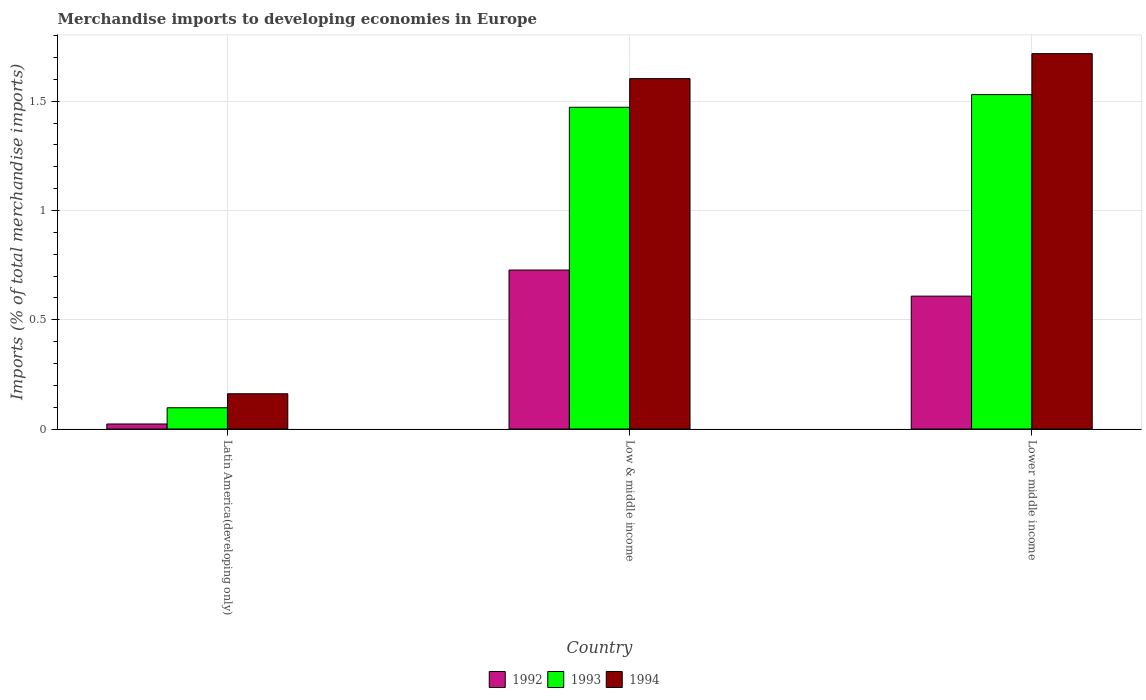How many different coloured bars are there?
Offer a terse response. 3. Are the number of bars per tick equal to the number of legend labels?
Offer a terse response. Yes. Are the number of bars on each tick of the X-axis equal?
Provide a short and direct response. Yes. What is the label of the 3rd group of bars from the left?
Provide a short and direct response. Lower middle income. What is the percentage total merchandise imports in 1994 in Lower middle income?
Make the answer very short. 1.72. Across all countries, what is the maximum percentage total merchandise imports in 1993?
Offer a very short reply. 1.53. Across all countries, what is the minimum percentage total merchandise imports in 1994?
Provide a short and direct response. 0.16. In which country was the percentage total merchandise imports in 1992 minimum?
Ensure brevity in your answer.  Latin America(developing only). What is the total percentage total merchandise imports in 1992 in the graph?
Keep it short and to the point. 1.36. What is the difference between the percentage total merchandise imports in 1992 in Latin America(developing only) and that in Lower middle income?
Offer a very short reply. -0.59. What is the difference between the percentage total merchandise imports in 1994 in Lower middle income and the percentage total merchandise imports in 1992 in Latin America(developing only)?
Your answer should be compact. 1.7. What is the average percentage total merchandise imports in 1993 per country?
Provide a short and direct response. 1.03. What is the difference between the percentage total merchandise imports of/in 1993 and percentage total merchandise imports of/in 1994 in Latin America(developing only)?
Give a very brief answer. -0.06. What is the ratio of the percentage total merchandise imports in 1994 in Latin America(developing only) to that in Lower middle income?
Offer a terse response. 0.09. Is the percentage total merchandise imports in 1994 in Latin America(developing only) less than that in Low & middle income?
Give a very brief answer. Yes. Is the difference between the percentage total merchandise imports in 1993 in Latin America(developing only) and Lower middle income greater than the difference between the percentage total merchandise imports in 1994 in Latin America(developing only) and Lower middle income?
Your answer should be very brief. Yes. What is the difference between the highest and the second highest percentage total merchandise imports in 1993?
Your response must be concise. -1.43. What is the difference between the highest and the lowest percentage total merchandise imports in 1994?
Provide a short and direct response. 1.56. In how many countries, is the percentage total merchandise imports in 1994 greater than the average percentage total merchandise imports in 1994 taken over all countries?
Offer a terse response. 2. How many bars are there?
Your answer should be compact. 9. Are all the bars in the graph horizontal?
Your answer should be very brief. No. What is the difference between two consecutive major ticks on the Y-axis?
Your answer should be compact. 0.5. Are the values on the major ticks of Y-axis written in scientific E-notation?
Provide a succinct answer. No. Does the graph contain any zero values?
Keep it short and to the point. No. Does the graph contain grids?
Ensure brevity in your answer.  Yes. What is the title of the graph?
Your answer should be compact. Merchandise imports to developing economies in Europe. What is the label or title of the Y-axis?
Offer a very short reply. Imports (% of total merchandise imports). What is the Imports (% of total merchandise imports) of 1992 in Latin America(developing only)?
Keep it short and to the point. 0.02. What is the Imports (% of total merchandise imports) in 1993 in Latin America(developing only)?
Provide a short and direct response. 0.1. What is the Imports (% of total merchandise imports) of 1994 in Latin America(developing only)?
Offer a very short reply. 0.16. What is the Imports (% of total merchandise imports) of 1992 in Low & middle income?
Give a very brief answer. 0.73. What is the Imports (% of total merchandise imports) in 1993 in Low & middle income?
Ensure brevity in your answer.  1.47. What is the Imports (% of total merchandise imports) of 1994 in Low & middle income?
Your answer should be very brief. 1.6. What is the Imports (% of total merchandise imports) in 1992 in Lower middle income?
Give a very brief answer. 0.61. What is the Imports (% of total merchandise imports) of 1993 in Lower middle income?
Provide a short and direct response. 1.53. What is the Imports (% of total merchandise imports) of 1994 in Lower middle income?
Offer a very short reply. 1.72. Across all countries, what is the maximum Imports (% of total merchandise imports) of 1992?
Your answer should be compact. 0.73. Across all countries, what is the maximum Imports (% of total merchandise imports) in 1993?
Keep it short and to the point. 1.53. Across all countries, what is the maximum Imports (% of total merchandise imports) in 1994?
Your answer should be compact. 1.72. Across all countries, what is the minimum Imports (% of total merchandise imports) of 1992?
Make the answer very short. 0.02. Across all countries, what is the minimum Imports (% of total merchandise imports) of 1993?
Provide a short and direct response. 0.1. Across all countries, what is the minimum Imports (% of total merchandise imports) of 1994?
Your response must be concise. 0.16. What is the total Imports (% of total merchandise imports) of 1992 in the graph?
Keep it short and to the point. 1.36. What is the total Imports (% of total merchandise imports) in 1993 in the graph?
Keep it short and to the point. 3.1. What is the total Imports (% of total merchandise imports) in 1994 in the graph?
Provide a succinct answer. 3.48. What is the difference between the Imports (% of total merchandise imports) in 1992 in Latin America(developing only) and that in Low & middle income?
Make the answer very short. -0.7. What is the difference between the Imports (% of total merchandise imports) of 1993 in Latin America(developing only) and that in Low & middle income?
Give a very brief answer. -1.38. What is the difference between the Imports (% of total merchandise imports) of 1994 in Latin America(developing only) and that in Low & middle income?
Your answer should be compact. -1.44. What is the difference between the Imports (% of total merchandise imports) in 1992 in Latin America(developing only) and that in Lower middle income?
Your answer should be compact. -0.59. What is the difference between the Imports (% of total merchandise imports) in 1993 in Latin America(developing only) and that in Lower middle income?
Your response must be concise. -1.43. What is the difference between the Imports (% of total merchandise imports) in 1994 in Latin America(developing only) and that in Lower middle income?
Your answer should be compact. -1.56. What is the difference between the Imports (% of total merchandise imports) of 1992 in Low & middle income and that in Lower middle income?
Offer a very short reply. 0.12. What is the difference between the Imports (% of total merchandise imports) in 1993 in Low & middle income and that in Lower middle income?
Keep it short and to the point. -0.06. What is the difference between the Imports (% of total merchandise imports) of 1994 in Low & middle income and that in Lower middle income?
Your response must be concise. -0.11. What is the difference between the Imports (% of total merchandise imports) in 1992 in Latin America(developing only) and the Imports (% of total merchandise imports) in 1993 in Low & middle income?
Offer a very short reply. -1.45. What is the difference between the Imports (% of total merchandise imports) in 1992 in Latin America(developing only) and the Imports (% of total merchandise imports) in 1994 in Low & middle income?
Offer a very short reply. -1.58. What is the difference between the Imports (% of total merchandise imports) in 1993 in Latin America(developing only) and the Imports (% of total merchandise imports) in 1994 in Low & middle income?
Provide a short and direct response. -1.51. What is the difference between the Imports (% of total merchandise imports) of 1992 in Latin America(developing only) and the Imports (% of total merchandise imports) of 1993 in Lower middle income?
Give a very brief answer. -1.51. What is the difference between the Imports (% of total merchandise imports) in 1992 in Latin America(developing only) and the Imports (% of total merchandise imports) in 1994 in Lower middle income?
Provide a succinct answer. -1.7. What is the difference between the Imports (% of total merchandise imports) of 1993 in Latin America(developing only) and the Imports (% of total merchandise imports) of 1994 in Lower middle income?
Provide a succinct answer. -1.62. What is the difference between the Imports (% of total merchandise imports) in 1992 in Low & middle income and the Imports (% of total merchandise imports) in 1993 in Lower middle income?
Ensure brevity in your answer.  -0.8. What is the difference between the Imports (% of total merchandise imports) of 1992 in Low & middle income and the Imports (% of total merchandise imports) of 1994 in Lower middle income?
Ensure brevity in your answer.  -0.99. What is the difference between the Imports (% of total merchandise imports) in 1993 in Low & middle income and the Imports (% of total merchandise imports) in 1994 in Lower middle income?
Your answer should be very brief. -0.25. What is the average Imports (% of total merchandise imports) in 1992 per country?
Offer a very short reply. 0.45. What is the average Imports (% of total merchandise imports) of 1993 per country?
Keep it short and to the point. 1.03. What is the average Imports (% of total merchandise imports) in 1994 per country?
Your answer should be compact. 1.16. What is the difference between the Imports (% of total merchandise imports) in 1992 and Imports (% of total merchandise imports) in 1993 in Latin America(developing only)?
Your response must be concise. -0.07. What is the difference between the Imports (% of total merchandise imports) of 1992 and Imports (% of total merchandise imports) of 1994 in Latin America(developing only)?
Provide a succinct answer. -0.14. What is the difference between the Imports (% of total merchandise imports) in 1993 and Imports (% of total merchandise imports) in 1994 in Latin America(developing only)?
Keep it short and to the point. -0.06. What is the difference between the Imports (% of total merchandise imports) of 1992 and Imports (% of total merchandise imports) of 1993 in Low & middle income?
Ensure brevity in your answer.  -0.74. What is the difference between the Imports (% of total merchandise imports) of 1992 and Imports (% of total merchandise imports) of 1994 in Low & middle income?
Offer a very short reply. -0.88. What is the difference between the Imports (% of total merchandise imports) of 1993 and Imports (% of total merchandise imports) of 1994 in Low & middle income?
Give a very brief answer. -0.13. What is the difference between the Imports (% of total merchandise imports) in 1992 and Imports (% of total merchandise imports) in 1993 in Lower middle income?
Ensure brevity in your answer.  -0.92. What is the difference between the Imports (% of total merchandise imports) of 1992 and Imports (% of total merchandise imports) of 1994 in Lower middle income?
Make the answer very short. -1.11. What is the difference between the Imports (% of total merchandise imports) of 1993 and Imports (% of total merchandise imports) of 1994 in Lower middle income?
Give a very brief answer. -0.19. What is the ratio of the Imports (% of total merchandise imports) in 1992 in Latin America(developing only) to that in Low & middle income?
Offer a terse response. 0.03. What is the ratio of the Imports (% of total merchandise imports) in 1993 in Latin America(developing only) to that in Low & middle income?
Your response must be concise. 0.07. What is the ratio of the Imports (% of total merchandise imports) of 1994 in Latin America(developing only) to that in Low & middle income?
Make the answer very short. 0.1. What is the ratio of the Imports (% of total merchandise imports) in 1992 in Latin America(developing only) to that in Lower middle income?
Keep it short and to the point. 0.04. What is the ratio of the Imports (% of total merchandise imports) of 1993 in Latin America(developing only) to that in Lower middle income?
Give a very brief answer. 0.06. What is the ratio of the Imports (% of total merchandise imports) of 1994 in Latin America(developing only) to that in Lower middle income?
Ensure brevity in your answer.  0.09. What is the ratio of the Imports (% of total merchandise imports) in 1992 in Low & middle income to that in Lower middle income?
Offer a very short reply. 1.2. What is the ratio of the Imports (% of total merchandise imports) of 1993 in Low & middle income to that in Lower middle income?
Provide a succinct answer. 0.96. What is the ratio of the Imports (% of total merchandise imports) of 1994 in Low & middle income to that in Lower middle income?
Give a very brief answer. 0.93. What is the difference between the highest and the second highest Imports (% of total merchandise imports) in 1992?
Ensure brevity in your answer.  0.12. What is the difference between the highest and the second highest Imports (% of total merchandise imports) in 1993?
Provide a short and direct response. 0.06. What is the difference between the highest and the second highest Imports (% of total merchandise imports) of 1994?
Your answer should be compact. 0.11. What is the difference between the highest and the lowest Imports (% of total merchandise imports) of 1992?
Your response must be concise. 0.7. What is the difference between the highest and the lowest Imports (% of total merchandise imports) of 1993?
Offer a very short reply. 1.43. What is the difference between the highest and the lowest Imports (% of total merchandise imports) of 1994?
Ensure brevity in your answer.  1.56. 